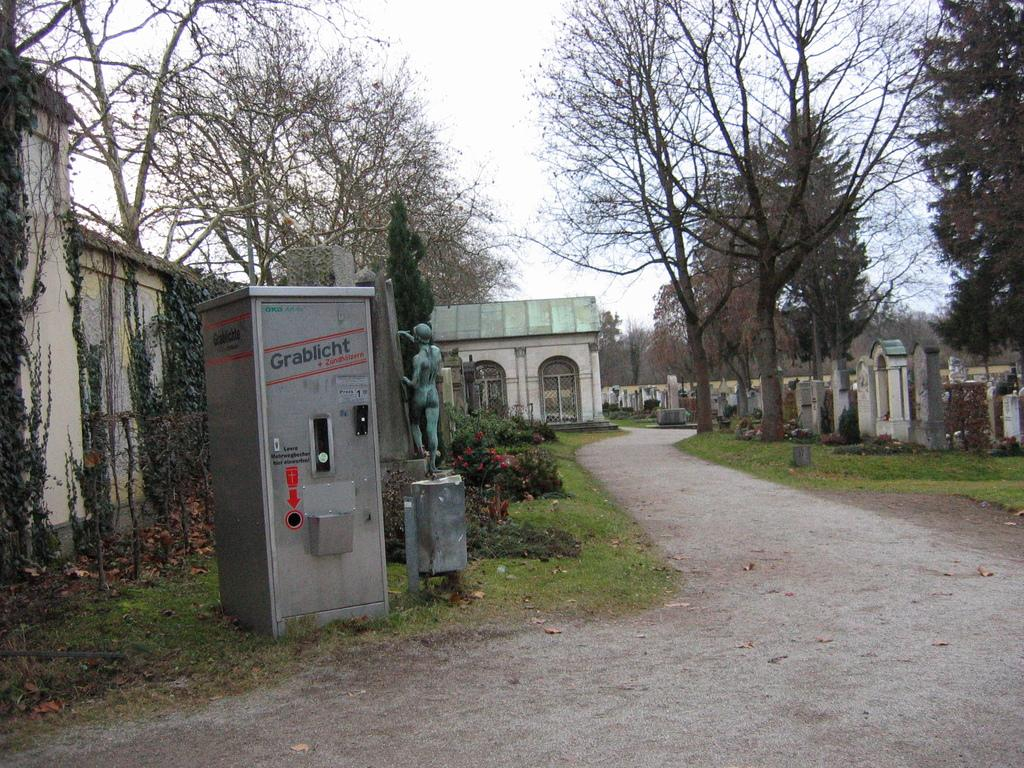Where was the image taken? The image was clicked outside. What can be seen in the middle of the image? There are trees, a small house-like structure, and a statue in the middle of the image. What is the structure in the middle of the image? It is a small house-like structure. What is visible at the top of the image? The sky is visible at the top of the image. What type of shock can be seen in the image? There is no shock present in the image. What hobbies are the trees in the image engaged in? Trees do not have hobbies, as they are inanimate objects. What instrument is the statue playing in the image? There is no instrument present in the image, as the statue is not depicted playing any instrument. 